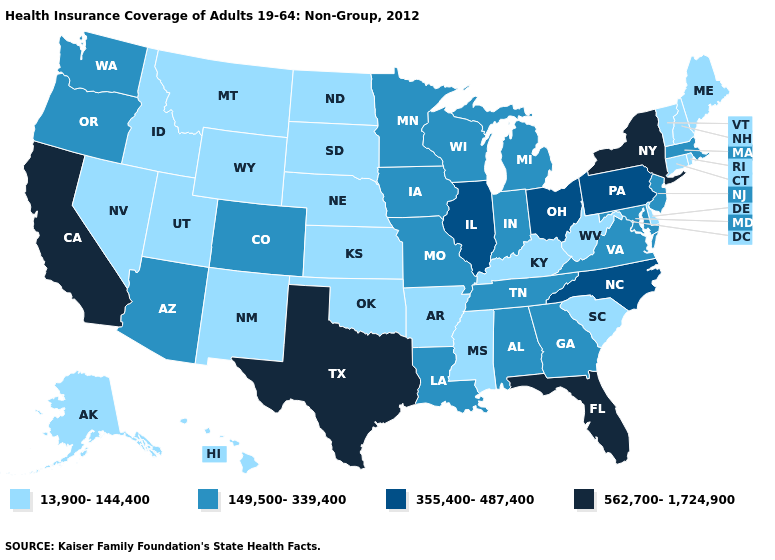What is the highest value in the South ?
Give a very brief answer. 562,700-1,724,900. Does Florida have the highest value in the USA?
Keep it brief. Yes. What is the highest value in the South ?
Write a very short answer. 562,700-1,724,900. Does North Dakota have the same value as Maryland?
Short answer required. No. Name the states that have a value in the range 355,400-487,400?
Write a very short answer. Illinois, North Carolina, Ohio, Pennsylvania. Does Utah have a higher value than Alaska?
Write a very short answer. No. What is the lowest value in the USA?
Write a very short answer. 13,900-144,400. Does Massachusetts have a higher value than Iowa?
Answer briefly. No. Among the states that border New Hampshire , which have the highest value?
Write a very short answer. Massachusetts. What is the value of Michigan?
Write a very short answer. 149,500-339,400. Among the states that border Alabama , does Mississippi have the lowest value?
Concise answer only. Yes. How many symbols are there in the legend?
Keep it brief. 4. Does the map have missing data?
Answer briefly. No. What is the lowest value in states that border Maryland?
Be succinct. 13,900-144,400. Does Arkansas have a lower value than Indiana?
Write a very short answer. Yes. 